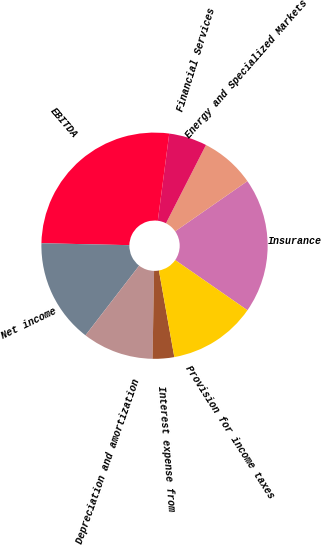<chart> <loc_0><loc_0><loc_500><loc_500><pie_chart><fcel>Insurance<fcel>Energy and Specialized Markets<fcel>Financial Services<fcel>EBITDA<fcel>Net income<fcel>Depreciation and amortization<fcel>Interest expense from<fcel>Provision for income taxes<nl><fcel>19.33%<fcel>7.81%<fcel>5.44%<fcel>26.73%<fcel>14.9%<fcel>10.17%<fcel>3.08%<fcel>12.54%<nl></chart> 